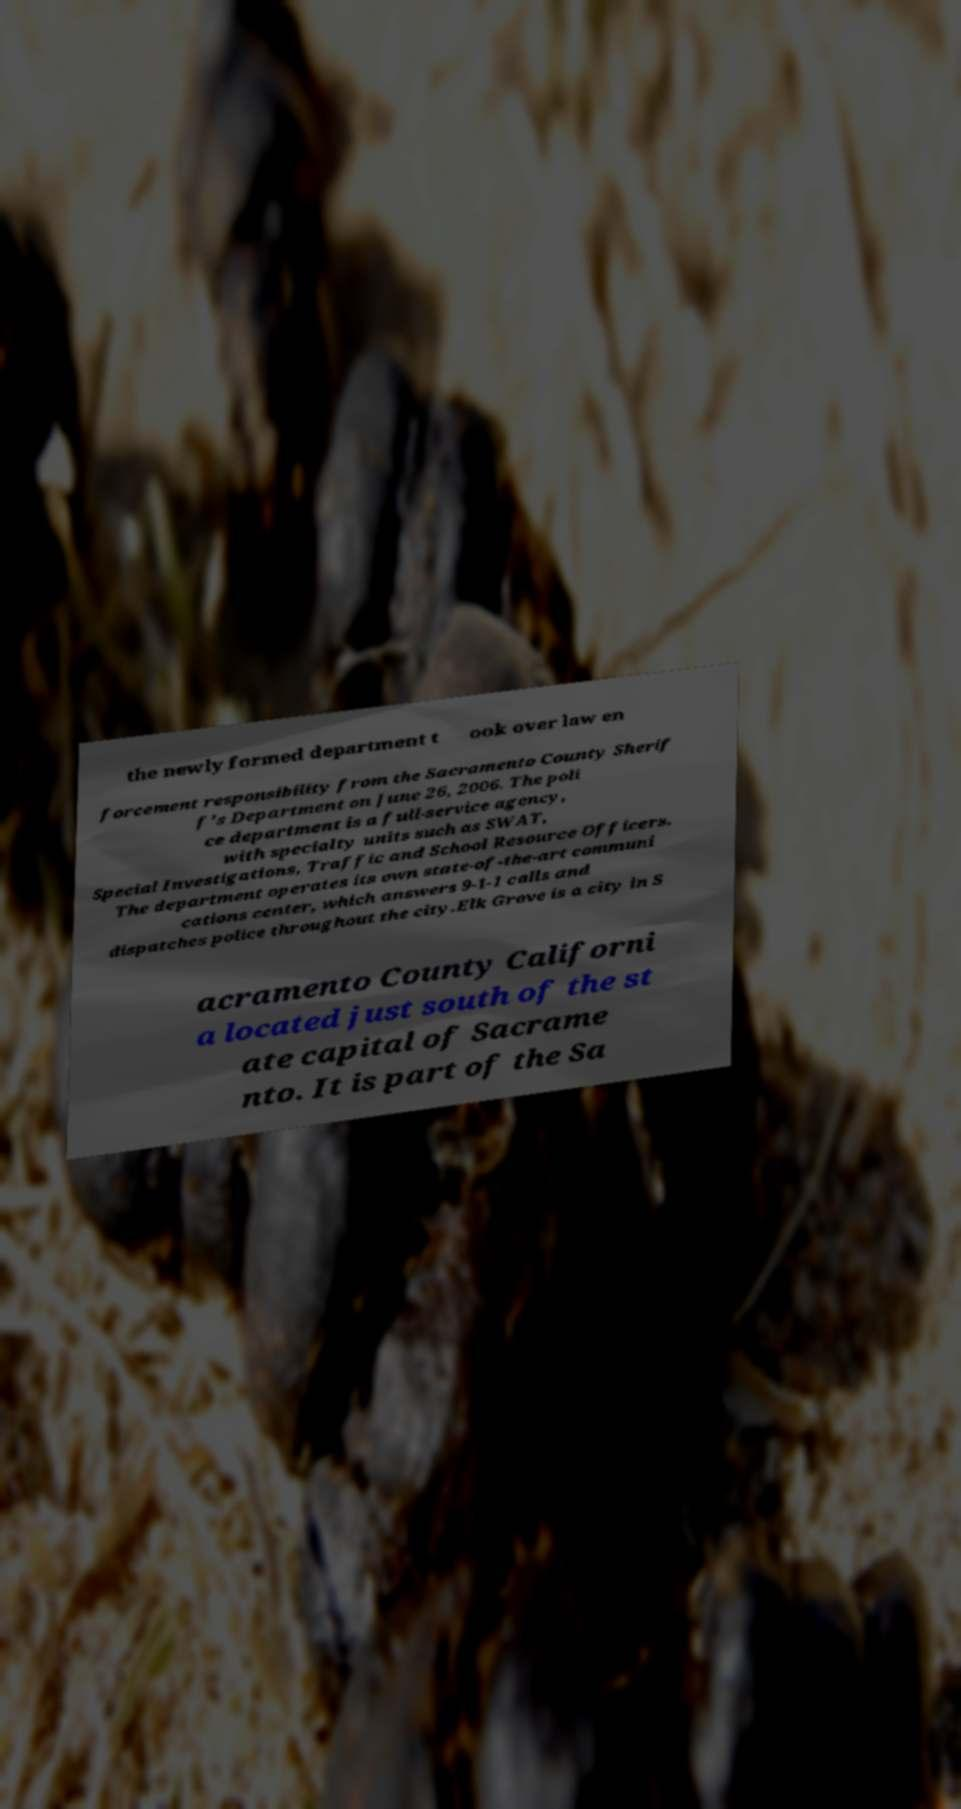Could you extract and type out the text from this image? the newly formed department t ook over law en forcement responsibility from the Sacramento County Sherif f's Department on June 26, 2006. The poli ce department is a full-service agency, with specialty units such as SWAT, Special Investigations, Traffic and School Resource Officers. The department operates its own state-of-the-art communi cations center, which answers 9-1-1 calls and dispatches police throughout the city.Elk Grove is a city in S acramento County Californi a located just south of the st ate capital of Sacrame nto. It is part of the Sa 